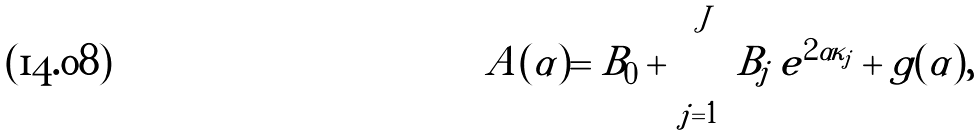Convert formula to latex. <formula><loc_0><loc_0><loc_500><loc_500>A ( \alpha ) = B _ { 0 } + \sum _ { j = 1 } ^ { J } B _ { j } \, e ^ { 2 \alpha \kappa _ { j } } + g ( \alpha ) ,</formula> 